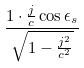<formula> <loc_0><loc_0><loc_500><loc_500>\frac { 1 \cdot \frac { j } { c } \cos \epsilon _ { s } } { \sqrt { 1 - \frac { j ^ { 2 } } { c ^ { 2 } } } }</formula> 